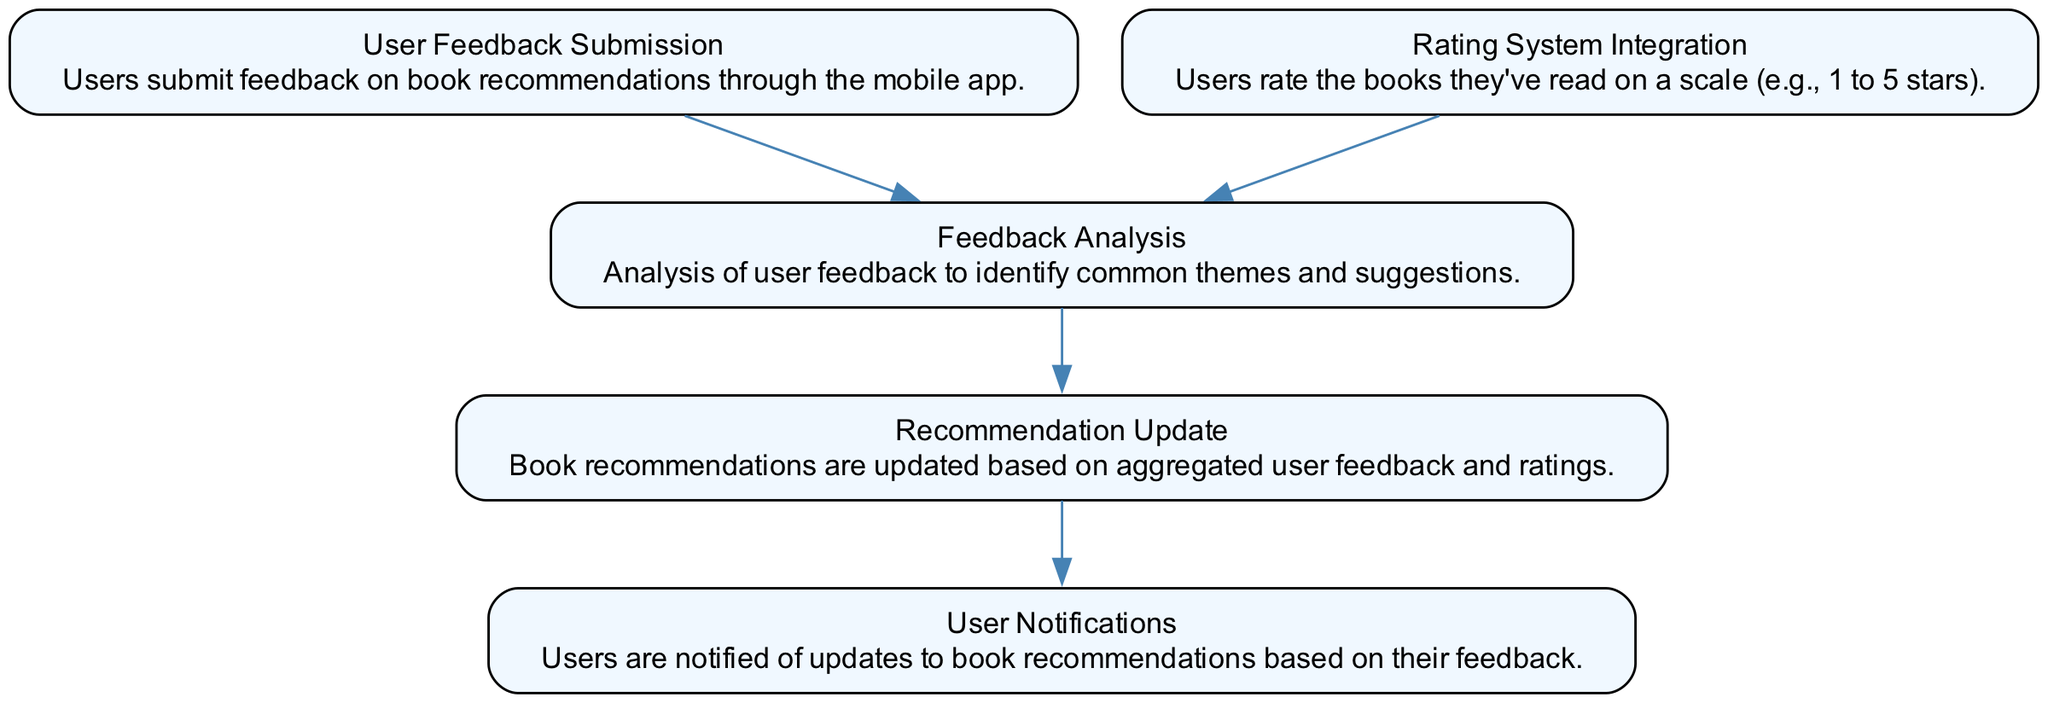What is the first node in the flow chart? The first node in the flow chart is labeled "User Feedback Submission". It is the starting point of the flow, indicating where users begin to interact with the process of providing feedback on book recommendations.
Answer: User Feedback Submission How many nodes are present in the diagram? By counting the distinct labeled nodes in the flow chart, there are five nodes: User Feedback Submission, Feedback Analysis, Rating System Integration, Recommendation Update, and User Notifications.
Answer: 5 Which node comes after "Feedback Analysis"? The node that follows "Feedback Analysis" in the flow of the diagram is "Recommendation Update". This indicates the sequential flow from analyzing the feedback to updating the recommendations based on that analysis.
Answer: Recommendation Update What relationship exists between "Rating System Integration" and "Feedback Analysis"? The relationship is a directed edge that shows "Rating System Integration" feeds into "Feedback Analysis". It indicates that user ratings contribute to the analysis of feedback.
Answer: Directed edge Which node sends notifications to users? The node that is responsible for sending notifications to users is "User Notifications", which is at the end of the flow, indicating it communicates updates based on aggregated user feedback and ratings.
Answer: User Notifications What triggers the "Recommendation Update" process? The process of "Recommendation Update" is triggered by the completion of both "Feedback Analysis" and the aggregated data from "Rating System Integration". This highlights the need for both feedback analysis and ratings to update book recommendations.
Answer: Feedback Analysis and Rating System Integration How many edges are there in the flow chart? There are four edges connecting the nodes in the flow chart: from User Feedback Submission to Feedback Analysis, from Rating System Integration to Feedback Analysis, from Feedback Analysis to Recommendation Update, and from Recommendation Update to User Notifications. Counting these connections gives the total number of edges.
Answer: 4 What kind of analysis is performed on the user feedback? The type of analysis performed on user feedback is qualitative, as it focuses on identifying common themes and suggestions from the collected feedback to inform book recommendations.
Answer: Common themes and suggestions What feedback leads to updates in book recommendations? Updates in book recommendations are based on aggregated user feedback and ratings, meaning that both the qualitative suggestions and quantitative ratings determine which books are recommended next.
Answer: Aggregated user feedback and ratings 